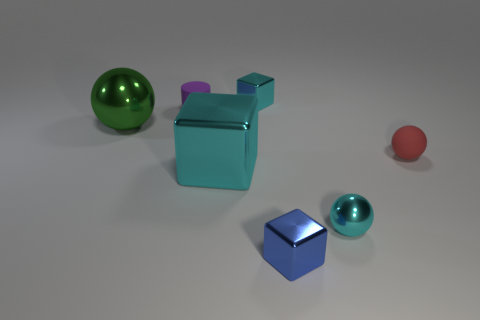There is a cyan metal thing right of the tiny cyan block; does it have the same shape as the small blue metal object? No, the shapes are different. The cyan object to the right of the tiny cyan block has a complex geometry that includes a cube and additional elements, whereas the small blue object is a perfect cube. 